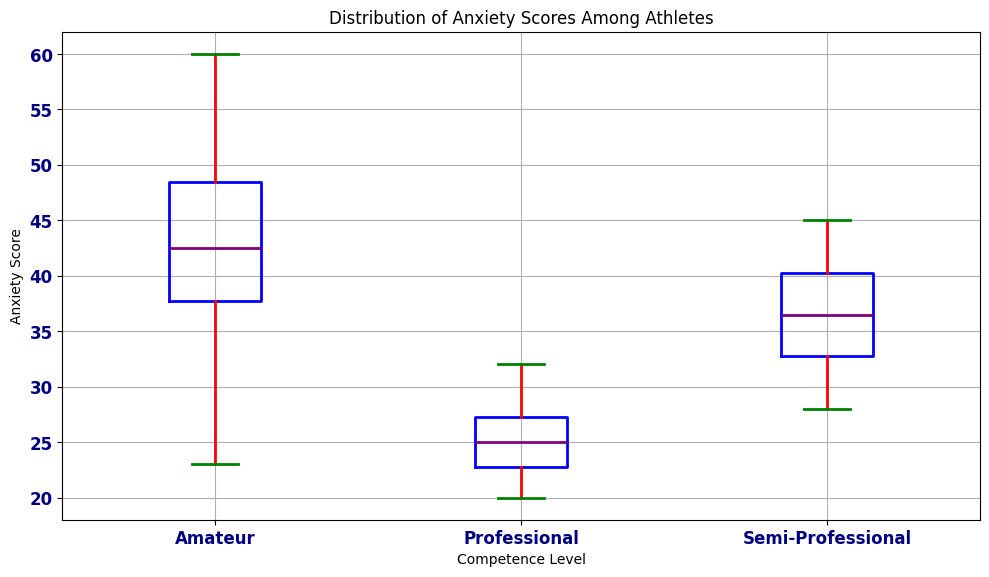What is the median anxiety score for amateur athletes? To find the median anxiety score for amateur athletes, look at the box plot for the "Amateur" group. The median is represented by the line inside the box.
Answer: 43 Which competence level group has the lowest median anxiety score? The groups are "Amateur," "Semi-Professional," and "Professional." Look at the median lines in each of their box plots. The lowest median line indicates the lowest median anxiety score. "Professional" has the lowest median score.
Answer: Professional How do the ranges of anxiety scores compare across the competence levels? To compare ranges, look at the lengths of the boxes and whiskers for each competence level. The range includes the minimum and maximum whisker endpoints. "Amateur" has a wider range than "Semi-Professional" and "Professional."
Answer: Amateur has the widest range, followed by Semi-Professional, then Professional What is the interquartile range (IQR) for semi-professional athletes? The IQR is the difference between the 75th percentile (top of the box) and the 25th percentile (bottom of the box). Look at the box plot for "Semi-Professional" and note these values.
Answer: 10 Which group has the highest maximum anxiety score and what is it? The maximum score is indicated by the top whisker or any fliers above it for each group. Check each competence level's plot for the maximum point. "Amateur" has the highest maximum score.
Answer: Amateur, 60 Do any of the competence levels have outliers in anxiety scores? If so, which ones? Outliers are marked as points outside the whiskers. Look for any such points in each group's box plot. Only the "Amateur" group has visible outliers.
Answer: Amateur What is the difference between the median anxiety scores of amateur and professional athletes? Calculate the medians of both groups and subtract the smaller from the larger. The median for "Amateur" is 43, and for "Professional" is approximately 24.5. The difference is 43 - 24.5.
Answer: 18.5 Which competence level has the most consistent anxiety scores? Consistency can be seen from the shortest box and whiskers, indicating less variability. "Professional" has the shortest box and whiskers.
Answer: Professional 